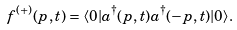Convert formula to latex. <formula><loc_0><loc_0><loc_500><loc_500>f ^ { ( + ) } ( p , t ) & = \langle 0 | a ^ { \dagger } ( p , t ) a ^ { \dagger } ( - p , t ) | 0 \rangle .</formula> 